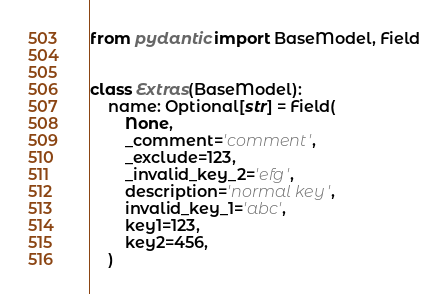<code> <loc_0><loc_0><loc_500><loc_500><_Python_>from pydantic import BaseModel, Field


class Extras(BaseModel):
    name: Optional[str] = Field(
        None,
        _comment='comment',
        _exclude=123,
        _invalid_key_2='efg',
        description='normal key',
        invalid_key_1='abc',
        key1=123,
        key2=456,
    )
</code> 